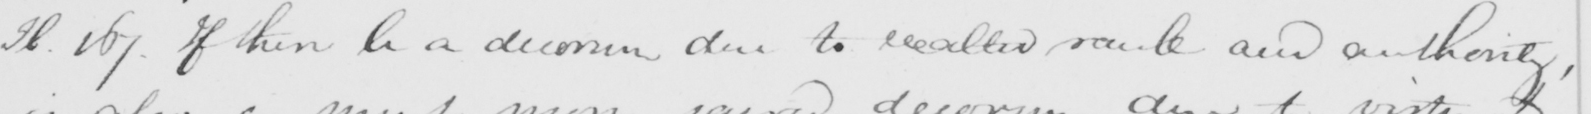Can you read and transcribe this handwriting? H . 167 . If there be a decorum due to exalted rank and authority , 